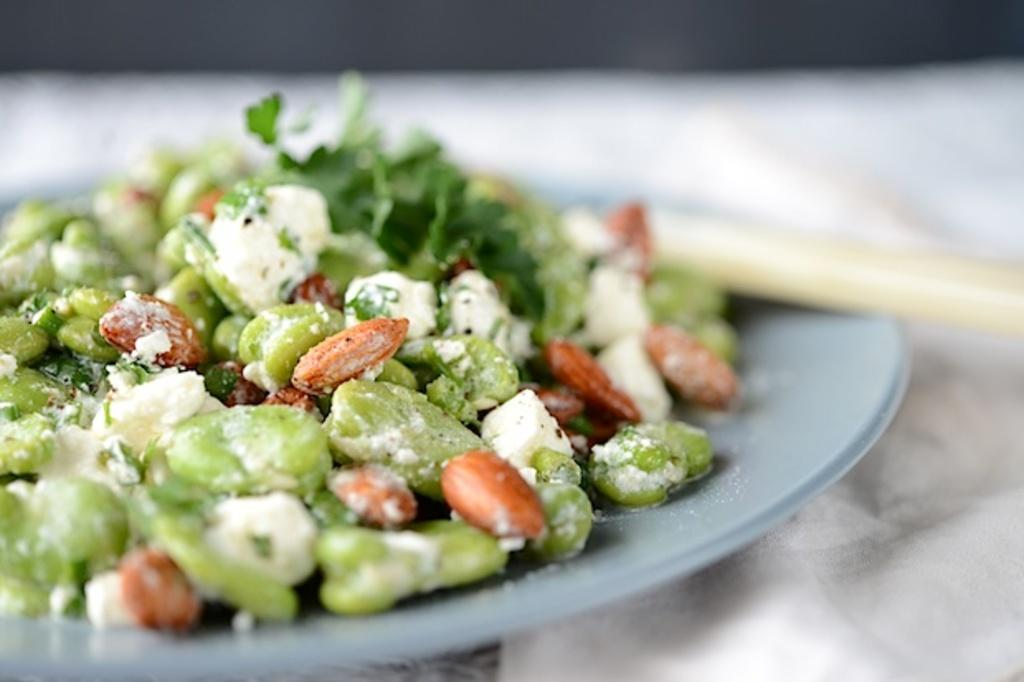What is placed on the plate in the image? There are eatables placed in a plate in the image. Can you describe any utensils visible in the image? Yes, there is a spoon in the right corner of the image. What type of agreement is being discussed by the scarecrow in the image? There is no scarecrow present in the image, so it is not possible to discuss any agreements. 